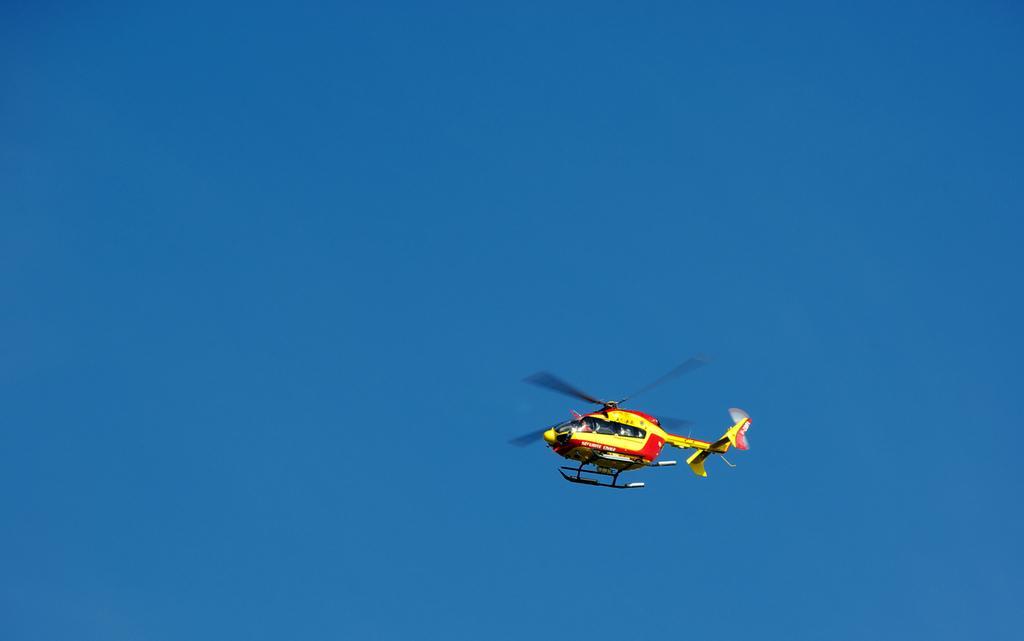Please provide a concise description of this image. In the center of the image we can see helicopter. In the background there is sky. 